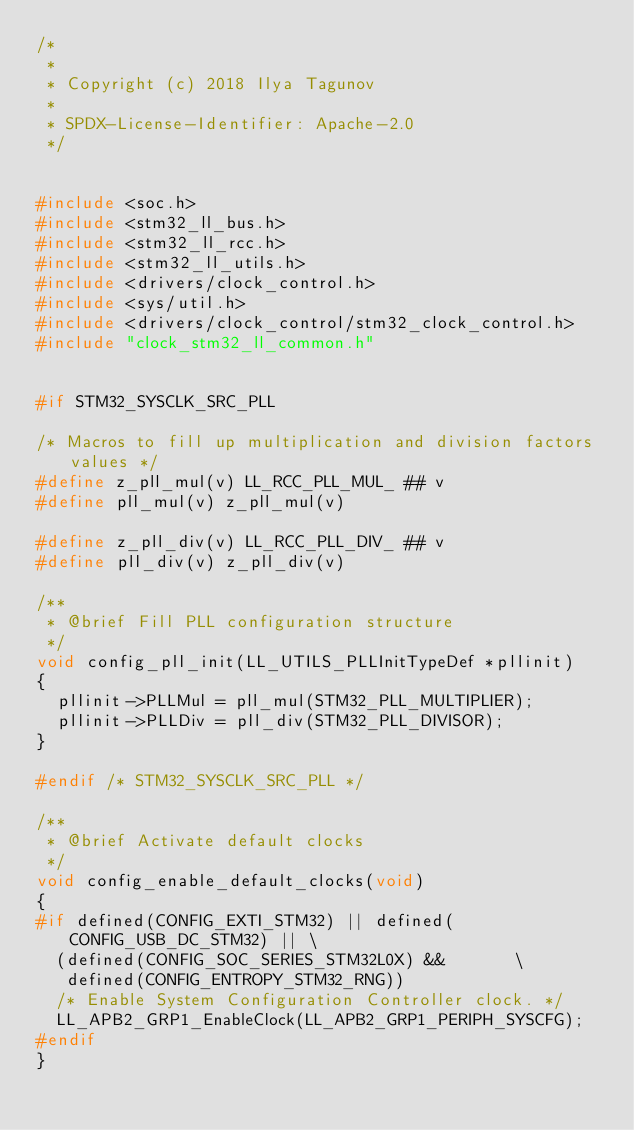Convert code to text. <code><loc_0><loc_0><loc_500><loc_500><_C_>/*
 *
 * Copyright (c) 2018 Ilya Tagunov
 *
 * SPDX-License-Identifier: Apache-2.0
 */


#include <soc.h>
#include <stm32_ll_bus.h>
#include <stm32_ll_rcc.h>
#include <stm32_ll_utils.h>
#include <drivers/clock_control.h>
#include <sys/util.h>
#include <drivers/clock_control/stm32_clock_control.h>
#include "clock_stm32_ll_common.h"


#if STM32_SYSCLK_SRC_PLL

/* Macros to fill up multiplication and division factors values */
#define z_pll_mul(v) LL_RCC_PLL_MUL_ ## v
#define pll_mul(v) z_pll_mul(v)

#define z_pll_div(v) LL_RCC_PLL_DIV_ ## v
#define pll_div(v) z_pll_div(v)

/**
 * @brief Fill PLL configuration structure
 */
void config_pll_init(LL_UTILS_PLLInitTypeDef *pllinit)
{
	pllinit->PLLMul = pll_mul(STM32_PLL_MULTIPLIER);
	pllinit->PLLDiv = pll_div(STM32_PLL_DIVISOR);
}

#endif /* STM32_SYSCLK_SRC_PLL */

/**
 * @brief Activate default clocks
 */
void config_enable_default_clocks(void)
{
#if defined(CONFIG_EXTI_STM32) || defined(CONFIG_USB_DC_STM32) || \
	(defined(CONFIG_SOC_SERIES_STM32L0X) &&			  \
	 defined(CONFIG_ENTROPY_STM32_RNG))
	/* Enable System Configuration Controller clock. */
	LL_APB2_GRP1_EnableClock(LL_APB2_GRP1_PERIPH_SYSCFG);
#endif
}
</code> 